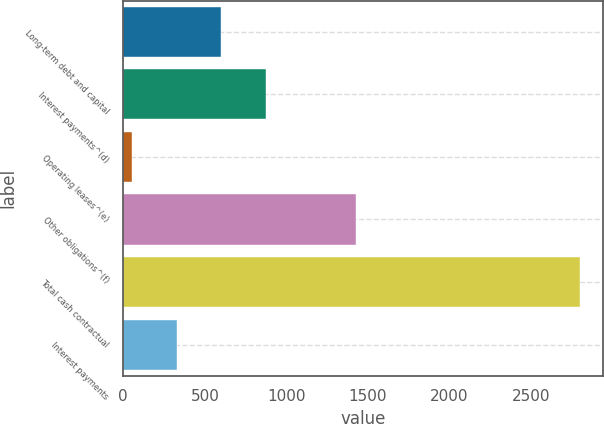Convert chart to OTSL. <chart><loc_0><loc_0><loc_500><loc_500><bar_chart><fcel>Long-term debt and capital<fcel>Interest payments^(d)<fcel>Operating leases^(e)<fcel>Other obligations^(f)<fcel>Total cash contractual<fcel>Interest payments<nl><fcel>601.6<fcel>876.4<fcel>52<fcel>1426<fcel>2800<fcel>326.8<nl></chart> 